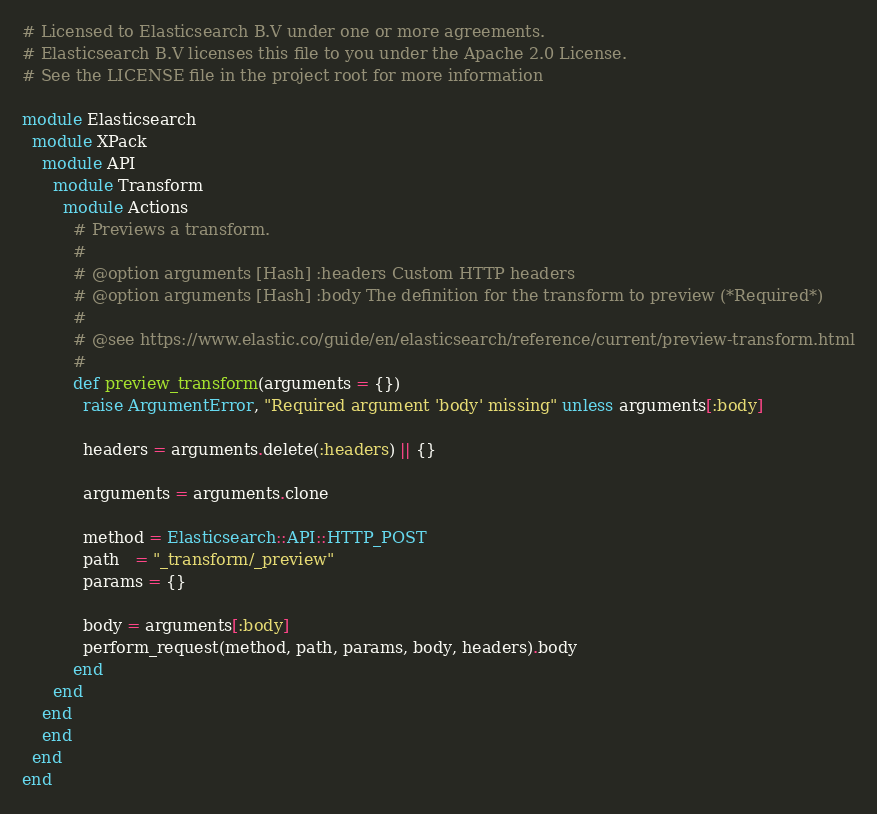<code> <loc_0><loc_0><loc_500><loc_500><_Ruby_># Licensed to Elasticsearch B.V under one or more agreements.
# Elasticsearch B.V licenses this file to you under the Apache 2.0 License.
# See the LICENSE file in the project root for more information

module Elasticsearch
  module XPack
    module API
      module Transform
        module Actions
          # Previews a transform.
          #
          # @option arguments [Hash] :headers Custom HTTP headers
          # @option arguments [Hash] :body The definition for the transform to preview (*Required*)
          #
          # @see https://www.elastic.co/guide/en/elasticsearch/reference/current/preview-transform.html
          #
          def preview_transform(arguments = {})
            raise ArgumentError, "Required argument 'body' missing" unless arguments[:body]

            headers = arguments.delete(:headers) || {}

            arguments = arguments.clone

            method = Elasticsearch::API::HTTP_POST
            path   = "_transform/_preview"
            params = {}

            body = arguments[:body]
            perform_request(method, path, params, body, headers).body
          end
      end
    end
    end
  end
end
</code> 